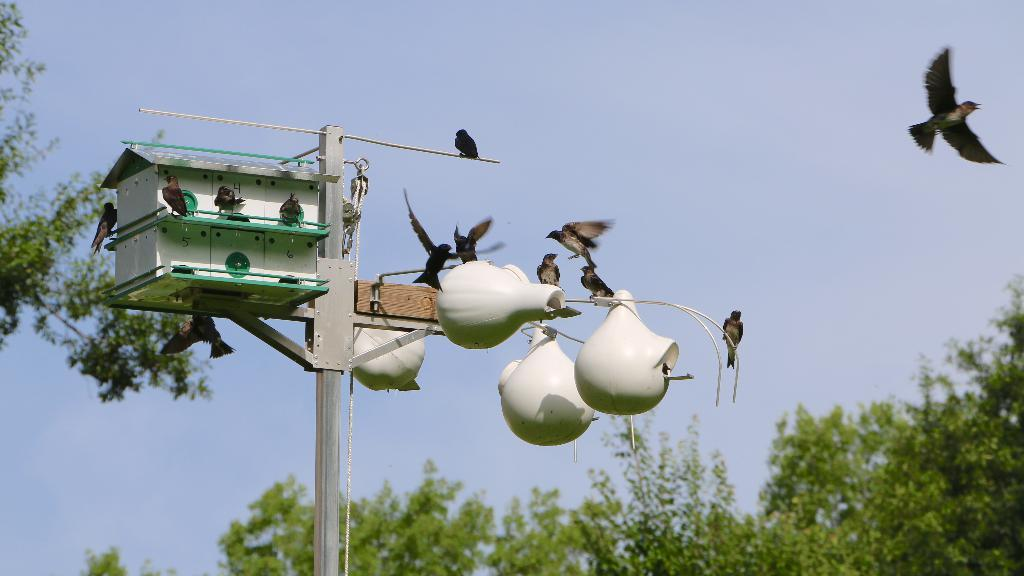What structure is present on the stand in the image? There is a birdhouse on a stand in the image. What are the birds doing in the image? Many birds are flying, and some are sitting on the birdhouse. What can be seen in the background of the image? There are trees and the sky visible in the background of the image. How much money is the birdhouse worth in the image? There is no information about the value of the birdhouse in the image, and money is not relevant to the scene depicted. 